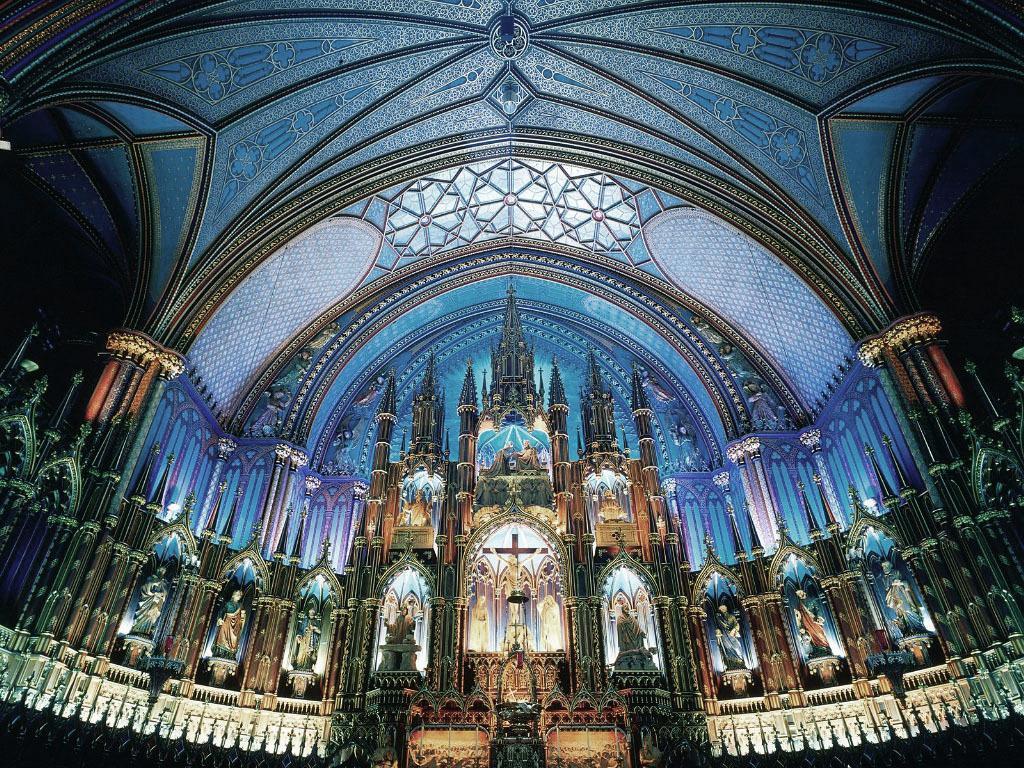Please provide a concise description of this image. This picture shows an inner view of a building. We see few statues and we see a designer ceiling. 